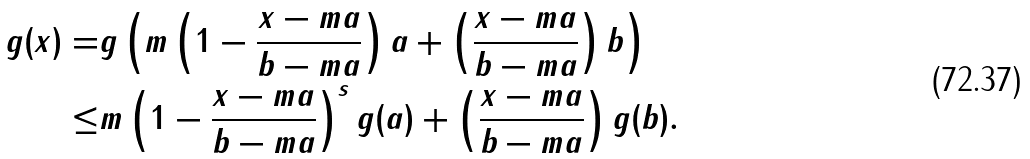<formula> <loc_0><loc_0><loc_500><loc_500>g ( x ) = & g \left ( m \left ( 1 - \frac { x - m a } { b - m a } \right ) a + \left ( \frac { x - m a } { b - m a } \right ) b \right ) \\ \leq & m \left ( 1 - \frac { x - m a } { b - m a } \right ) ^ { s } g ( a ) + \left ( \frac { x - m a } { b - m a } \right ) g ( b ) .</formula> 